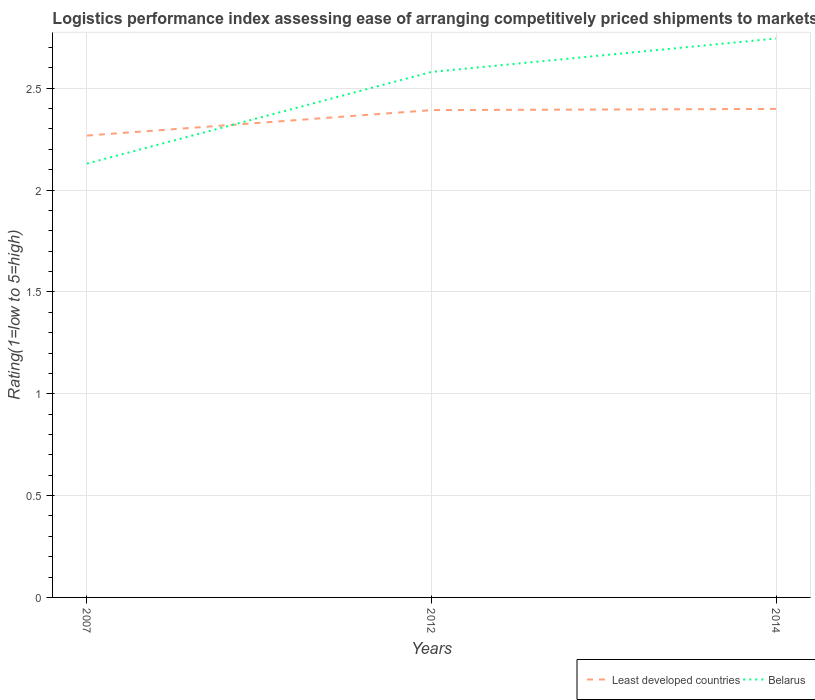How many different coloured lines are there?
Provide a succinct answer. 2. Across all years, what is the maximum Logistic performance index in Least developed countries?
Your answer should be very brief. 2.27. What is the total Logistic performance index in Least developed countries in the graph?
Provide a short and direct response. -0.13. What is the difference between the highest and the second highest Logistic performance index in Least developed countries?
Your answer should be very brief. 0.13. How many years are there in the graph?
Your answer should be compact. 3. What is the difference between two consecutive major ticks on the Y-axis?
Provide a succinct answer. 0.5. Are the values on the major ticks of Y-axis written in scientific E-notation?
Offer a terse response. No. Does the graph contain grids?
Offer a terse response. Yes. Where does the legend appear in the graph?
Keep it short and to the point. Bottom right. How are the legend labels stacked?
Provide a short and direct response. Horizontal. What is the title of the graph?
Give a very brief answer. Logistics performance index assessing ease of arranging competitively priced shipments to markets. Does "Haiti" appear as one of the legend labels in the graph?
Your answer should be very brief. No. What is the label or title of the Y-axis?
Provide a succinct answer. Rating(1=low to 5=high). What is the Rating(1=low to 5=high) in Least developed countries in 2007?
Give a very brief answer. 2.27. What is the Rating(1=low to 5=high) of Belarus in 2007?
Offer a terse response. 2.13. What is the Rating(1=low to 5=high) in Least developed countries in 2012?
Your answer should be very brief. 2.39. What is the Rating(1=low to 5=high) of Belarus in 2012?
Offer a very short reply. 2.58. What is the Rating(1=low to 5=high) in Least developed countries in 2014?
Offer a terse response. 2.4. What is the Rating(1=low to 5=high) of Belarus in 2014?
Ensure brevity in your answer.  2.74. Across all years, what is the maximum Rating(1=low to 5=high) in Least developed countries?
Make the answer very short. 2.4. Across all years, what is the maximum Rating(1=low to 5=high) of Belarus?
Make the answer very short. 2.74. Across all years, what is the minimum Rating(1=low to 5=high) in Least developed countries?
Provide a succinct answer. 2.27. Across all years, what is the minimum Rating(1=low to 5=high) of Belarus?
Your response must be concise. 2.13. What is the total Rating(1=low to 5=high) of Least developed countries in the graph?
Your answer should be very brief. 7.06. What is the total Rating(1=low to 5=high) of Belarus in the graph?
Your answer should be compact. 7.45. What is the difference between the Rating(1=low to 5=high) in Least developed countries in 2007 and that in 2012?
Offer a terse response. -0.12. What is the difference between the Rating(1=low to 5=high) in Belarus in 2007 and that in 2012?
Offer a terse response. -0.45. What is the difference between the Rating(1=low to 5=high) in Least developed countries in 2007 and that in 2014?
Your answer should be very brief. -0.13. What is the difference between the Rating(1=low to 5=high) in Belarus in 2007 and that in 2014?
Provide a succinct answer. -0.61. What is the difference between the Rating(1=low to 5=high) of Least developed countries in 2012 and that in 2014?
Offer a very short reply. -0.01. What is the difference between the Rating(1=low to 5=high) in Belarus in 2012 and that in 2014?
Provide a short and direct response. -0.16. What is the difference between the Rating(1=low to 5=high) in Least developed countries in 2007 and the Rating(1=low to 5=high) in Belarus in 2012?
Offer a terse response. -0.31. What is the difference between the Rating(1=low to 5=high) of Least developed countries in 2007 and the Rating(1=low to 5=high) of Belarus in 2014?
Keep it short and to the point. -0.48. What is the difference between the Rating(1=low to 5=high) in Least developed countries in 2012 and the Rating(1=low to 5=high) in Belarus in 2014?
Your response must be concise. -0.35. What is the average Rating(1=low to 5=high) in Least developed countries per year?
Ensure brevity in your answer.  2.35. What is the average Rating(1=low to 5=high) in Belarus per year?
Provide a succinct answer. 2.48. In the year 2007, what is the difference between the Rating(1=low to 5=high) in Least developed countries and Rating(1=low to 5=high) in Belarus?
Give a very brief answer. 0.14. In the year 2012, what is the difference between the Rating(1=low to 5=high) in Least developed countries and Rating(1=low to 5=high) in Belarus?
Your answer should be very brief. -0.19. In the year 2014, what is the difference between the Rating(1=low to 5=high) in Least developed countries and Rating(1=low to 5=high) in Belarus?
Provide a short and direct response. -0.35. What is the ratio of the Rating(1=low to 5=high) of Least developed countries in 2007 to that in 2012?
Your response must be concise. 0.95. What is the ratio of the Rating(1=low to 5=high) of Belarus in 2007 to that in 2012?
Provide a succinct answer. 0.83. What is the ratio of the Rating(1=low to 5=high) of Least developed countries in 2007 to that in 2014?
Keep it short and to the point. 0.95. What is the ratio of the Rating(1=low to 5=high) in Belarus in 2007 to that in 2014?
Your answer should be very brief. 0.78. What is the ratio of the Rating(1=low to 5=high) of Belarus in 2012 to that in 2014?
Make the answer very short. 0.94. What is the difference between the highest and the second highest Rating(1=low to 5=high) in Least developed countries?
Provide a short and direct response. 0.01. What is the difference between the highest and the second highest Rating(1=low to 5=high) of Belarus?
Provide a succinct answer. 0.16. What is the difference between the highest and the lowest Rating(1=low to 5=high) in Least developed countries?
Provide a succinct answer. 0.13. What is the difference between the highest and the lowest Rating(1=low to 5=high) of Belarus?
Your answer should be very brief. 0.61. 